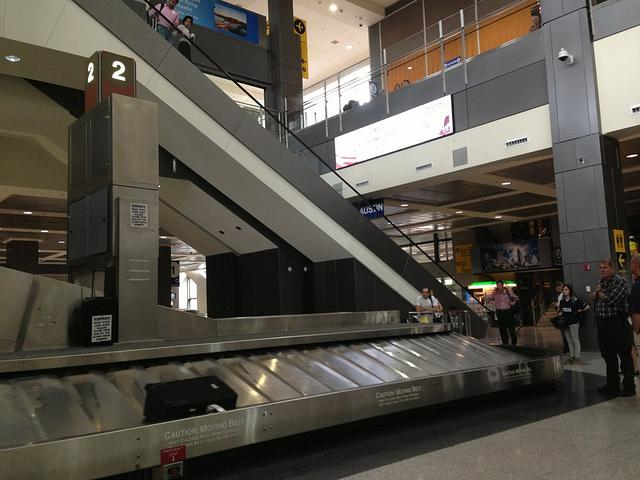What color is the suitcase on the luggage rack underneath the number two? black 